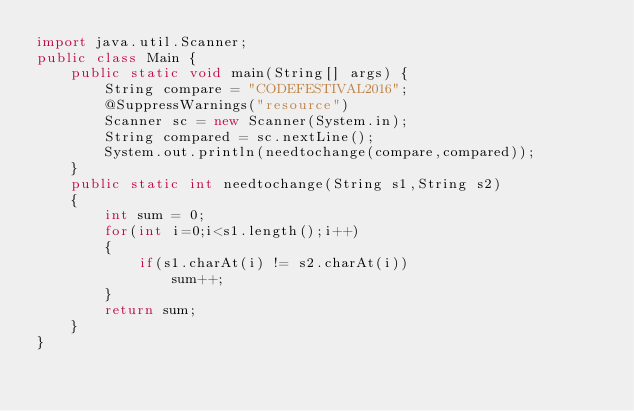<code> <loc_0><loc_0><loc_500><loc_500><_Java_>import java.util.Scanner;
public class Main {
	public static void main(String[] args) {
		String compare = "CODEFESTIVAL2016";
		@SuppressWarnings("resource")
		Scanner sc = new Scanner(System.in);
		String compared = sc.nextLine();
		System.out.println(needtochange(compare,compared));
	}
	public static int needtochange(String s1,String s2)
	{
		int sum = 0;
		for(int i=0;i<s1.length();i++)
		{
			if(s1.charAt(i) != s2.charAt(i))
				sum++;
		}
		return sum;
	}
}
</code> 